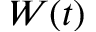Convert formula to latex. <formula><loc_0><loc_0><loc_500><loc_500>W ( t )</formula> 